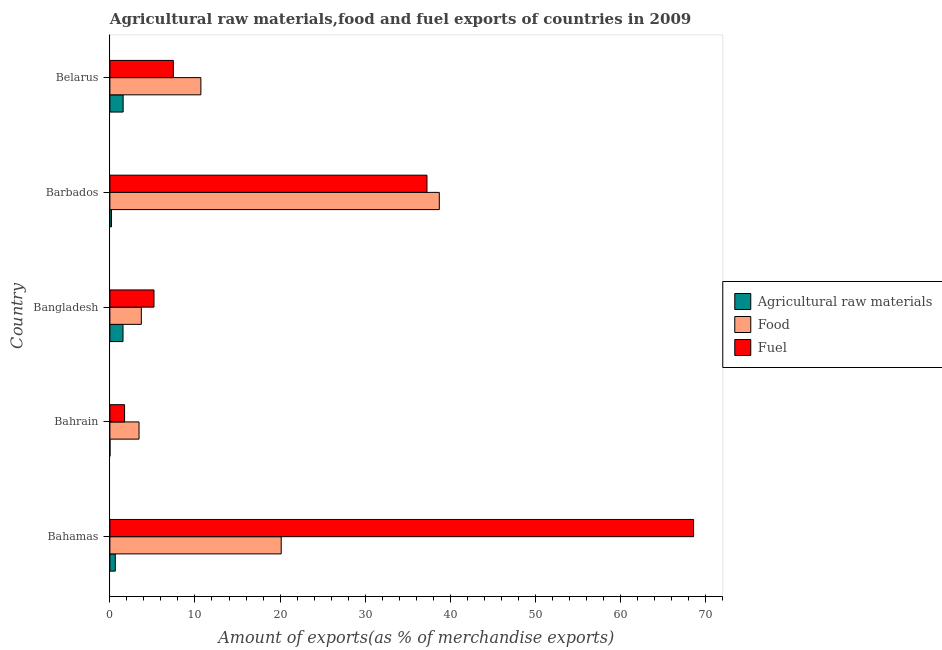Are the number of bars per tick equal to the number of legend labels?
Provide a short and direct response. Yes. How many bars are there on the 1st tick from the top?
Make the answer very short. 3. What is the label of the 4th group of bars from the top?
Ensure brevity in your answer.  Bahrain. In how many cases, is the number of bars for a given country not equal to the number of legend labels?
Keep it short and to the point. 0. What is the percentage of food exports in Belarus?
Ensure brevity in your answer.  10.69. Across all countries, what is the maximum percentage of food exports?
Ensure brevity in your answer.  38.72. Across all countries, what is the minimum percentage of food exports?
Keep it short and to the point. 3.42. In which country was the percentage of food exports maximum?
Your response must be concise. Barbados. In which country was the percentage of fuel exports minimum?
Offer a terse response. Bahrain. What is the total percentage of food exports in the graph?
Offer a very short reply. 76.67. What is the difference between the percentage of fuel exports in Bahrain and that in Belarus?
Provide a succinct answer. -5.73. What is the difference between the percentage of raw materials exports in Barbados and the percentage of food exports in Belarus?
Provide a short and direct response. -10.51. What is the average percentage of fuel exports per country?
Offer a very short reply. 24.05. What is the difference between the percentage of food exports and percentage of fuel exports in Belarus?
Ensure brevity in your answer.  3.23. What is the ratio of the percentage of food exports in Bahamas to that in Barbados?
Provide a short and direct response. 0.52. Is the difference between the percentage of raw materials exports in Bangladesh and Barbados greater than the difference between the percentage of food exports in Bangladesh and Barbados?
Provide a short and direct response. Yes. What is the difference between the highest and the second highest percentage of fuel exports?
Make the answer very short. 31.34. What is the difference between the highest and the lowest percentage of raw materials exports?
Your response must be concise. 1.55. Is the sum of the percentage of fuel exports in Bangladesh and Belarus greater than the maximum percentage of food exports across all countries?
Provide a succinct answer. No. What does the 2nd bar from the top in Bahamas represents?
Your response must be concise. Food. What does the 3rd bar from the bottom in Belarus represents?
Give a very brief answer. Fuel. Is it the case that in every country, the sum of the percentage of raw materials exports and percentage of food exports is greater than the percentage of fuel exports?
Keep it short and to the point. No. Does the graph contain any zero values?
Make the answer very short. No. How many legend labels are there?
Provide a short and direct response. 3. What is the title of the graph?
Provide a succinct answer. Agricultural raw materials,food and fuel exports of countries in 2009. What is the label or title of the X-axis?
Provide a short and direct response. Amount of exports(as % of merchandise exports). What is the label or title of the Y-axis?
Make the answer very short. Country. What is the Amount of exports(as % of merchandise exports) in Agricultural raw materials in Bahamas?
Make the answer very short. 0.64. What is the Amount of exports(as % of merchandise exports) in Food in Bahamas?
Offer a very short reply. 20.14. What is the Amount of exports(as % of merchandise exports) of Fuel in Bahamas?
Your answer should be compact. 68.6. What is the Amount of exports(as % of merchandise exports) in Agricultural raw materials in Bahrain?
Your response must be concise. 0.01. What is the Amount of exports(as % of merchandise exports) in Food in Bahrain?
Your answer should be compact. 3.42. What is the Amount of exports(as % of merchandise exports) in Fuel in Bahrain?
Your answer should be very brief. 1.73. What is the Amount of exports(as % of merchandise exports) of Agricultural raw materials in Bangladesh?
Your answer should be very brief. 1.54. What is the Amount of exports(as % of merchandise exports) of Food in Bangladesh?
Provide a succinct answer. 3.69. What is the Amount of exports(as % of merchandise exports) in Fuel in Bangladesh?
Ensure brevity in your answer.  5.18. What is the Amount of exports(as % of merchandise exports) in Agricultural raw materials in Barbados?
Provide a short and direct response. 0.19. What is the Amount of exports(as % of merchandise exports) of Food in Barbados?
Your answer should be compact. 38.72. What is the Amount of exports(as % of merchandise exports) in Fuel in Barbados?
Provide a succinct answer. 37.27. What is the Amount of exports(as % of merchandise exports) in Agricultural raw materials in Belarus?
Make the answer very short. 1.56. What is the Amount of exports(as % of merchandise exports) of Food in Belarus?
Provide a short and direct response. 10.69. What is the Amount of exports(as % of merchandise exports) of Fuel in Belarus?
Offer a terse response. 7.46. Across all countries, what is the maximum Amount of exports(as % of merchandise exports) in Agricultural raw materials?
Your answer should be very brief. 1.56. Across all countries, what is the maximum Amount of exports(as % of merchandise exports) of Food?
Your answer should be very brief. 38.72. Across all countries, what is the maximum Amount of exports(as % of merchandise exports) in Fuel?
Your answer should be very brief. 68.6. Across all countries, what is the minimum Amount of exports(as % of merchandise exports) in Agricultural raw materials?
Give a very brief answer. 0.01. Across all countries, what is the minimum Amount of exports(as % of merchandise exports) in Food?
Your answer should be very brief. 3.42. Across all countries, what is the minimum Amount of exports(as % of merchandise exports) in Fuel?
Your response must be concise. 1.73. What is the total Amount of exports(as % of merchandise exports) in Agricultural raw materials in the graph?
Offer a terse response. 3.93. What is the total Amount of exports(as % of merchandise exports) in Food in the graph?
Provide a short and direct response. 76.67. What is the total Amount of exports(as % of merchandise exports) in Fuel in the graph?
Your response must be concise. 120.24. What is the difference between the Amount of exports(as % of merchandise exports) of Agricultural raw materials in Bahamas and that in Bahrain?
Offer a very short reply. 0.63. What is the difference between the Amount of exports(as % of merchandise exports) in Food in Bahamas and that in Bahrain?
Ensure brevity in your answer.  16.71. What is the difference between the Amount of exports(as % of merchandise exports) in Fuel in Bahamas and that in Bahrain?
Offer a terse response. 66.88. What is the difference between the Amount of exports(as % of merchandise exports) of Agricultural raw materials in Bahamas and that in Bangladesh?
Make the answer very short. -0.91. What is the difference between the Amount of exports(as % of merchandise exports) of Food in Bahamas and that in Bangladesh?
Provide a succinct answer. 16.44. What is the difference between the Amount of exports(as % of merchandise exports) of Fuel in Bahamas and that in Bangladesh?
Keep it short and to the point. 63.42. What is the difference between the Amount of exports(as % of merchandise exports) of Agricultural raw materials in Bahamas and that in Barbados?
Ensure brevity in your answer.  0.45. What is the difference between the Amount of exports(as % of merchandise exports) of Food in Bahamas and that in Barbados?
Give a very brief answer. -18.58. What is the difference between the Amount of exports(as % of merchandise exports) in Fuel in Bahamas and that in Barbados?
Make the answer very short. 31.34. What is the difference between the Amount of exports(as % of merchandise exports) of Agricultural raw materials in Bahamas and that in Belarus?
Offer a very short reply. -0.92. What is the difference between the Amount of exports(as % of merchandise exports) of Food in Bahamas and that in Belarus?
Offer a very short reply. 9.44. What is the difference between the Amount of exports(as % of merchandise exports) of Fuel in Bahamas and that in Belarus?
Provide a short and direct response. 61.14. What is the difference between the Amount of exports(as % of merchandise exports) of Agricultural raw materials in Bahrain and that in Bangladesh?
Provide a short and direct response. -1.53. What is the difference between the Amount of exports(as % of merchandise exports) of Food in Bahrain and that in Bangladesh?
Make the answer very short. -0.27. What is the difference between the Amount of exports(as % of merchandise exports) of Fuel in Bahrain and that in Bangladesh?
Your answer should be compact. -3.46. What is the difference between the Amount of exports(as % of merchandise exports) of Agricultural raw materials in Bahrain and that in Barbados?
Make the answer very short. -0.18. What is the difference between the Amount of exports(as % of merchandise exports) in Food in Bahrain and that in Barbados?
Your answer should be compact. -35.29. What is the difference between the Amount of exports(as % of merchandise exports) in Fuel in Bahrain and that in Barbados?
Make the answer very short. -35.54. What is the difference between the Amount of exports(as % of merchandise exports) in Agricultural raw materials in Bahrain and that in Belarus?
Make the answer very short. -1.55. What is the difference between the Amount of exports(as % of merchandise exports) in Food in Bahrain and that in Belarus?
Make the answer very short. -7.27. What is the difference between the Amount of exports(as % of merchandise exports) in Fuel in Bahrain and that in Belarus?
Keep it short and to the point. -5.73. What is the difference between the Amount of exports(as % of merchandise exports) of Agricultural raw materials in Bangladesh and that in Barbados?
Keep it short and to the point. 1.35. What is the difference between the Amount of exports(as % of merchandise exports) of Food in Bangladesh and that in Barbados?
Your answer should be very brief. -35.02. What is the difference between the Amount of exports(as % of merchandise exports) in Fuel in Bangladesh and that in Barbados?
Keep it short and to the point. -32.08. What is the difference between the Amount of exports(as % of merchandise exports) of Agricultural raw materials in Bangladesh and that in Belarus?
Provide a succinct answer. -0.01. What is the difference between the Amount of exports(as % of merchandise exports) of Food in Bangladesh and that in Belarus?
Offer a terse response. -7. What is the difference between the Amount of exports(as % of merchandise exports) in Fuel in Bangladesh and that in Belarus?
Provide a short and direct response. -2.27. What is the difference between the Amount of exports(as % of merchandise exports) in Agricultural raw materials in Barbados and that in Belarus?
Give a very brief answer. -1.37. What is the difference between the Amount of exports(as % of merchandise exports) of Food in Barbados and that in Belarus?
Make the answer very short. 28.02. What is the difference between the Amount of exports(as % of merchandise exports) of Fuel in Barbados and that in Belarus?
Provide a short and direct response. 29.81. What is the difference between the Amount of exports(as % of merchandise exports) in Agricultural raw materials in Bahamas and the Amount of exports(as % of merchandise exports) in Food in Bahrain?
Keep it short and to the point. -2.79. What is the difference between the Amount of exports(as % of merchandise exports) in Agricultural raw materials in Bahamas and the Amount of exports(as % of merchandise exports) in Fuel in Bahrain?
Your answer should be compact. -1.09. What is the difference between the Amount of exports(as % of merchandise exports) of Food in Bahamas and the Amount of exports(as % of merchandise exports) of Fuel in Bahrain?
Keep it short and to the point. 18.41. What is the difference between the Amount of exports(as % of merchandise exports) of Agricultural raw materials in Bahamas and the Amount of exports(as % of merchandise exports) of Food in Bangladesh?
Provide a succinct answer. -3.06. What is the difference between the Amount of exports(as % of merchandise exports) of Agricultural raw materials in Bahamas and the Amount of exports(as % of merchandise exports) of Fuel in Bangladesh?
Give a very brief answer. -4.55. What is the difference between the Amount of exports(as % of merchandise exports) of Food in Bahamas and the Amount of exports(as % of merchandise exports) of Fuel in Bangladesh?
Make the answer very short. 14.95. What is the difference between the Amount of exports(as % of merchandise exports) in Agricultural raw materials in Bahamas and the Amount of exports(as % of merchandise exports) in Food in Barbados?
Provide a short and direct response. -38.08. What is the difference between the Amount of exports(as % of merchandise exports) in Agricultural raw materials in Bahamas and the Amount of exports(as % of merchandise exports) in Fuel in Barbados?
Your answer should be very brief. -36.63. What is the difference between the Amount of exports(as % of merchandise exports) of Food in Bahamas and the Amount of exports(as % of merchandise exports) of Fuel in Barbados?
Give a very brief answer. -17.13. What is the difference between the Amount of exports(as % of merchandise exports) in Agricultural raw materials in Bahamas and the Amount of exports(as % of merchandise exports) in Food in Belarus?
Your answer should be compact. -10.06. What is the difference between the Amount of exports(as % of merchandise exports) in Agricultural raw materials in Bahamas and the Amount of exports(as % of merchandise exports) in Fuel in Belarus?
Offer a very short reply. -6.82. What is the difference between the Amount of exports(as % of merchandise exports) in Food in Bahamas and the Amount of exports(as % of merchandise exports) in Fuel in Belarus?
Your answer should be compact. 12.68. What is the difference between the Amount of exports(as % of merchandise exports) of Agricultural raw materials in Bahrain and the Amount of exports(as % of merchandise exports) of Food in Bangladesh?
Your answer should be compact. -3.68. What is the difference between the Amount of exports(as % of merchandise exports) in Agricultural raw materials in Bahrain and the Amount of exports(as % of merchandise exports) in Fuel in Bangladesh?
Offer a terse response. -5.17. What is the difference between the Amount of exports(as % of merchandise exports) in Food in Bahrain and the Amount of exports(as % of merchandise exports) in Fuel in Bangladesh?
Keep it short and to the point. -1.76. What is the difference between the Amount of exports(as % of merchandise exports) of Agricultural raw materials in Bahrain and the Amount of exports(as % of merchandise exports) of Food in Barbados?
Offer a terse response. -38.71. What is the difference between the Amount of exports(as % of merchandise exports) in Agricultural raw materials in Bahrain and the Amount of exports(as % of merchandise exports) in Fuel in Barbados?
Your answer should be very brief. -37.26. What is the difference between the Amount of exports(as % of merchandise exports) in Food in Bahrain and the Amount of exports(as % of merchandise exports) in Fuel in Barbados?
Offer a very short reply. -33.84. What is the difference between the Amount of exports(as % of merchandise exports) of Agricultural raw materials in Bahrain and the Amount of exports(as % of merchandise exports) of Food in Belarus?
Your response must be concise. -10.68. What is the difference between the Amount of exports(as % of merchandise exports) of Agricultural raw materials in Bahrain and the Amount of exports(as % of merchandise exports) of Fuel in Belarus?
Offer a very short reply. -7.45. What is the difference between the Amount of exports(as % of merchandise exports) in Food in Bahrain and the Amount of exports(as % of merchandise exports) in Fuel in Belarus?
Give a very brief answer. -4.03. What is the difference between the Amount of exports(as % of merchandise exports) in Agricultural raw materials in Bangladesh and the Amount of exports(as % of merchandise exports) in Food in Barbados?
Offer a very short reply. -37.18. What is the difference between the Amount of exports(as % of merchandise exports) of Agricultural raw materials in Bangladesh and the Amount of exports(as % of merchandise exports) of Fuel in Barbados?
Your answer should be compact. -35.72. What is the difference between the Amount of exports(as % of merchandise exports) in Food in Bangladesh and the Amount of exports(as % of merchandise exports) in Fuel in Barbados?
Your response must be concise. -33.57. What is the difference between the Amount of exports(as % of merchandise exports) of Agricultural raw materials in Bangladesh and the Amount of exports(as % of merchandise exports) of Food in Belarus?
Your response must be concise. -9.15. What is the difference between the Amount of exports(as % of merchandise exports) in Agricultural raw materials in Bangladesh and the Amount of exports(as % of merchandise exports) in Fuel in Belarus?
Offer a terse response. -5.92. What is the difference between the Amount of exports(as % of merchandise exports) in Food in Bangladesh and the Amount of exports(as % of merchandise exports) in Fuel in Belarus?
Keep it short and to the point. -3.76. What is the difference between the Amount of exports(as % of merchandise exports) in Agricultural raw materials in Barbados and the Amount of exports(as % of merchandise exports) in Food in Belarus?
Make the answer very short. -10.51. What is the difference between the Amount of exports(as % of merchandise exports) of Agricultural raw materials in Barbados and the Amount of exports(as % of merchandise exports) of Fuel in Belarus?
Provide a short and direct response. -7.27. What is the difference between the Amount of exports(as % of merchandise exports) in Food in Barbados and the Amount of exports(as % of merchandise exports) in Fuel in Belarus?
Provide a short and direct response. 31.26. What is the average Amount of exports(as % of merchandise exports) in Agricultural raw materials per country?
Your response must be concise. 0.79. What is the average Amount of exports(as % of merchandise exports) in Food per country?
Your response must be concise. 15.33. What is the average Amount of exports(as % of merchandise exports) of Fuel per country?
Provide a succinct answer. 24.05. What is the difference between the Amount of exports(as % of merchandise exports) in Agricultural raw materials and Amount of exports(as % of merchandise exports) in Food in Bahamas?
Your response must be concise. -19.5. What is the difference between the Amount of exports(as % of merchandise exports) in Agricultural raw materials and Amount of exports(as % of merchandise exports) in Fuel in Bahamas?
Your response must be concise. -67.97. What is the difference between the Amount of exports(as % of merchandise exports) in Food and Amount of exports(as % of merchandise exports) in Fuel in Bahamas?
Provide a succinct answer. -48.47. What is the difference between the Amount of exports(as % of merchandise exports) in Agricultural raw materials and Amount of exports(as % of merchandise exports) in Food in Bahrain?
Offer a very short reply. -3.41. What is the difference between the Amount of exports(as % of merchandise exports) of Agricultural raw materials and Amount of exports(as % of merchandise exports) of Fuel in Bahrain?
Provide a short and direct response. -1.72. What is the difference between the Amount of exports(as % of merchandise exports) of Food and Amount of exports(as % of merchandise exports) of Fuel in Bahrain?
Your answer should be compact. 1.7. What is the difference between the Amount of exports(as % of merchandise exports) in Agricultural raw materials and Amount of exports(as % of merchandise exports) in Food in Bangladesh?
Provide a short and direct response. -2.15. What is the difference between the Amount of exports(as % of merchandise exports) of Agricultural raw materials and Amount of exports(as % of merchandise exports) of Fuel in Bangladesh?
Your answer should be very brief. -3.64. What is the difference between the Amount of exports(as % of merchandise exports) in Food and Amount of exports(as % of merchandise exports) in Fuel in Bangladesh?
Make the answer very short. -1.49. What is the difference between the Amount of exports(as % of merchandise exports) of Agricultural raw materials and Amount of exports(as % of merchandise exports) of Food in Barbados?
Provide a short and direct response. -38.53. What is the difference between the Amount of exports(as % of merchandise exports) in Agricultural raw materials and Amount of exports(as % of merchandise exports) in Fuel in Barbados?
Make the answer very short. -37.08. What is the difference between the Amount of exports(as % of merchandise exports) of Food and Amount of exports(as % of merchandise exports) of Fuel in Barbados?
Offer a terse response. 1.45. What is the difference between the Amount of exports(as % of merchandise exports) of Agricultural raw materials and Amount of exports(as % of merchandise exports) of Food in Belarus?
Make the answer very short. -9.14. What is the difference between the Amount of exports(as % of merchandise exports) in Agricultural raw materials and Amount of exports(as % of merchandise exports) in Fuel in Belarus?
Your response must be concise. -5.9. What is the difference between the Amount of exports(as % of merchandise exports) in Food and Amount of exports(as % of merchandise exports) in Fuel in Belarus?
Give a very brief answer. 3.24. What is the ratio of the Amount of exports(as % of merchandise exports) of Agricultural raw materials in Bahamas to that in Bahrain?
Offer a terse response. 57.56. What is the ratio of the Amount of exports(as % of merchandise exports) of Food in Bahamas to that in Bahrain?
Offer a terse response. 5.88. What is the ratio of the Amount of exports(as % of merchandise exports) in Fuel in Bahamas to that in Bahrain?
Your answer should be compact. 39.73. What is the ratio of the Amount of exports(as % of merchandise exports) in Agricultural raw materials in Bahamas to that in Bangladesh?
Make the answer very short. 0.41. What is the ratio of the Amount of exports(as % of merchandise exports) of Food in Bahamas to that in Bangladesh?
Provide a succinct answer. 5.45. What is the ratio of the Amount of exports(as % of merchandise exports) in Fuel in Bahamas to that in Bangladesh?
Ensure brevity in your answer.  13.23. What is the ratio of the Amount of exports(as % of merchandise exports) in Agricultural raw materials in Bahamas to that in Barbados?
Your answer should be compact. 3.4. What is the ratio of the Amount of exports(as % of merchandise exports) of Food in Bahamas to that in Barbados?
Offer a very short reply. 0.52. What is the ratio of the Amount of exports(as % of merchandise exports) in Fuel in Bahamas to that in Barbados?
Offer a very short reply. 1.84. What is the ratio of the Amount of exports(as % of merchandise exports) in Agricultural raw materials in Bahamas to that in Belarus?
Offer a very short reply. 0.41. What is the ratio of the Amount of exports(as % of merchandise exports) of Food in Bahamas to that in Belarus?
Provide a succinct answer. 1.88. What is the ratio of the Amount of exports(as % of merchandise exports) of Fuel in Bahamas to that in Belarus?
Provide a succinct answer. 9.2. What is the ratio of the Amount of exports(as % of merchandise exports) in Agricultural raw materials in Bahrain to that in Bangladesh?
Make the answer very short. 0.01. What is the ratio of the Amount of exports(as % of merchandise exports) in Food in Bahrain to that in Bangladesh?
Offer a very short reply. 0.93. What is the ratio of the Amount of exports(as % of merchandise exports) of Fuel in Bahrain to that in Bangladesh?
Your answer should be compact. 0.33. What is the ratio of the Amount of exports(as % of merchandise exports) in Agricultural raw materials in Bahrain to that in Barbados?
Ensure brevity in your answer.  0.06. What is the ratio of the Amount of exports(as % of merchandise exports) of Food in Bahrain to that in Barbados?
Offer a terse response. 0.09. What is the ratio of the Amount of exports(as % of merchandise exports) in Fuel in Bahrain to that in Barbados?
Provide a short and direct response. 0.05. What is the ratio of the Amount of exports(as % of merchandise exports) of Agricultural raw materials in Bahrain to that in Belarus?
Offer a very short reply. 0.01. What is the ratio of the Amount of exports(as % of merchandise exports) in Food in Bahrain to that in Belarus?
Provide a short and direct response. 0.32. What is the ratio of the Amount of exports(as % of merchandise exports) in Fuel in Bahrain to that in Belarus?
Your answer should be very brief. 0.23. What is the ratio of the Amount of exports(as % of merchandise exports) of Agricultural raw materials in Bangladesh to that in Barbados?
Keep it short and to the point. 8.23. What is the ratio of the Amount of exports(as % of merchandise exports) of Food in Bangladesh to that in Barbados?
Provide a short and direct response. 0.1. What is the ratio of the Amount of exports(as % of merchandise exports) of Fuel in Bangladesh to that in Barbados?
Provide a short and direct response. 0.14. What is the ratio of the Amount of exports(as % of merchandise exports) of Agricultural raw materials in Bangladesh to that in Belarus?
Provide a succinct answer. 0.99. What is the ratio of the Amount of exports(as % of merchandise exports) in Food in Bangladesh to that in Belarus?
Your answer should be compact. 0.35. What is the ratio of the Amount of exports(as % of merchandise exports) of Fuel in Bangladesh to that in Belarus?
Offer a terse response. 0.7. What is the ratio of the Amount of exports(as % of merchandise exports) in Agricultural raw materials in Barbados to that in Belarus?
Give a very brief answer. 0.12. What is the ratio of the Amount of exports(as % of merchandise exports) of Food in Barbados to that in Belarus?
Provide a short and direct response. 3.62. What is the ratio of the Amount of exports(as % of merchandise exports) of Fuel in Barbados to that in Belarus?
Your answer should be very brief. 5. What is the difference between the highest and the second highest Amount of exports(as % of merchandise exports) in Agricultural raw materials?
Your answer should be compact. 0.01. What is the difference between the highest and the second highest Amount of exports(as % of merchandise exports) of Food?
Keep it short and to the point. 18.58. What is the difference between the highest and the second highest Amount of exports(as % of merchandise exports) of Fuel?
Keep it short and to the point. 31.34. What is the difference between the highest and the lowest Amount of exports(as % of merchandise exports) in Agricultural raw materials?
Provide a short and direct response. 1.55. What is the difference between the highest and the lowest Amount of exports(as % of merchandise exports) of Food?
Your answer should be compact. 35.29. What is the difference between the highest and the lowest Amount of exports(as % of merchandise exports) of Fuel?
Provide a succinct answer. 66.88. 